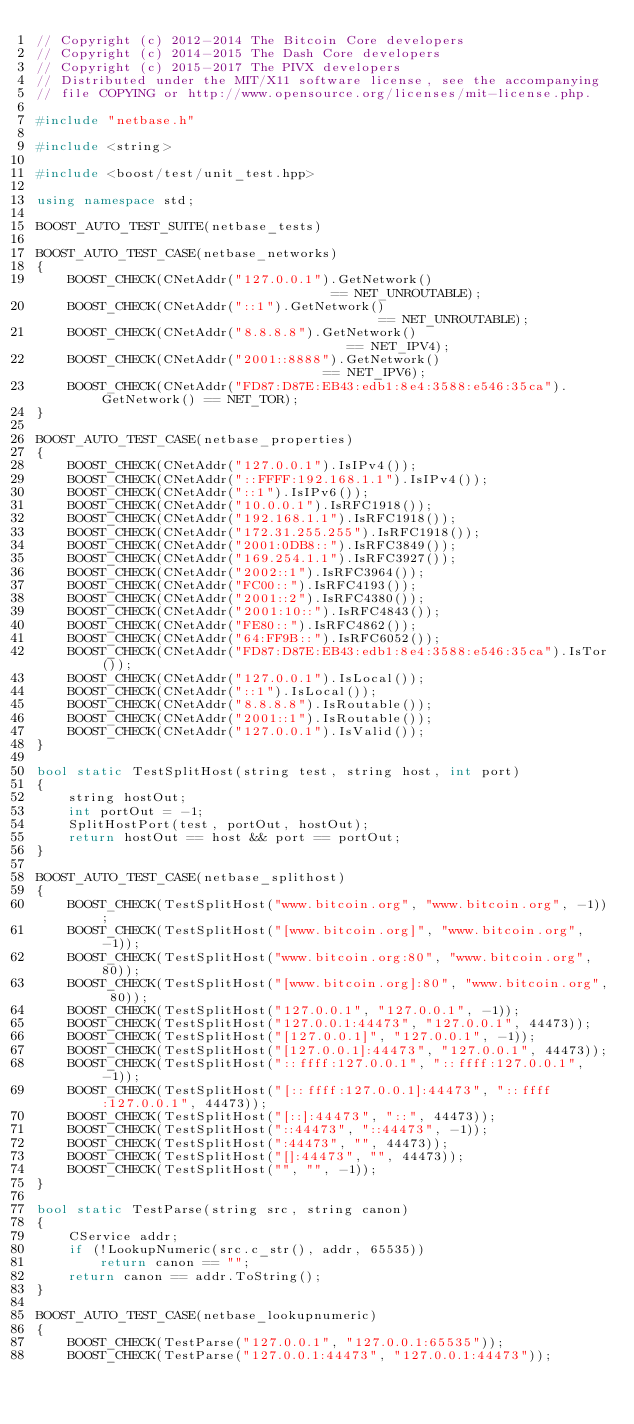Convert code to text. <code><loc_0><loc_0><loc_500><loc_500><_C++_>// Copyright (c) 2012-2014 The Bitcoin Core developers
// Copyright (c) 2014-2015 The Dash Core developers
// Copyright (c) 2015-2017 The PIVX developers
// Distributed under the MIT/X11 software license, see the accompanying
// file COPYING or http://www.opensource.org/licenses/mit-license.php.

#include "netbase.h"

#include <string>

#include <boost/test/unit_test.hpp>

using namespace std;

BOOST_AUTO_TEST_SUITE(netbase_tests)

BOOST_AUTO_TEST_CASE(netbase_networks)
{
    BOOST_CHECK(CNetAddr("127.0.0.1").GetNetwork()                              == NET_UNROUTABLE);
    BOOST_CHECK(CNetAddr("::1").GetNetwork()                                    == NET_UNROUTABLE);
    BOOST_CHECK(CNetAddr("8.8.8.8").GetNetwork()                                == NET_IPV4);
    BOOST_CHECK(CNetAddr("2001::8888").GetNetwork()                             == NET_IPV6);
    BOOST_CHECK(CNetAddr("FD87:D87E:EB43:edb1:8e4:3588:e546:35ca").GetNetwork() == NET_TOR);
}

BOOST_AUTO_TEST_CASE(netbase_properties)
{
    BOOST_CHECK(CNetAddr("127.0.0.1").IsIPv4());
    BOOST_CHECK(CNetAddr("::FFFF:192.168.1.1").IsIPv4());
    BOOST_CHECK(CNetAddr("::1").IsIPv6());
    BOOST_CHECK(CNetAddr("10.0.0.1").IsRFC1918());
    BOOST_CHECK(CNetAddr("192.168.1.1").IsRFC1918());
    BOOST_CHECK(CNetAddr("172.31.255.255").IsRFC1918());
    BOOST_CHECK(CNetAddr("2001:0DB8::").IsRFC3849());
    BOOST_CHECK(CNetAddr("169.254.1.1").IsRFC3927());
    BOOST_CHECK(CNetAddr("2002::1").IsRFC3964());
    BOOST_CHECK(CNetAddr("FC00::").IsRFC4193());
    BOOST_CHECK(CNetAddr("2001::2").IsRFC4380());
    BOOST_CHECK(CNetAddr("2001:10::").IsRFC4843());
    BOOST_CHECK(CNetAddr("FE80::").IsRFC4862());
    BOOST_CHECK(CNetAddr("64:FF9B::").IsRFC6052());
    BOOST_CHECK(CNetAddr("FD87:D87E:EB43:edb1:8e4:3588:e546:35ca").IsTor());
    BOOST_CHECK(CNetAddr("127.0.0.1").IsLocal());
    BOOST_CHECK(CNetAddr("::1").IsLocal());
    BOOST_CHECK(CNetAddr("8.8.8.8").IsRoutable());
    BOOST_CHECK(CNetAddr("2001::1").IsRoutable());
    BOOST_CHECK(CNetAddr("127.0.0.1").IsValid());
}

bool static TestSplitHost(string test, string host, int port)
{
    string hostOut;
    int portOut = -1;
    SplitHostPort(test, portOut, hostOut);
    return hostOut == host && port == portOut;
}

BOOST_AUTO_TEST_CASE(netbase_splithost)
{
    BOOST_CHECK(TestSplitHost("www.bitcoin.org", "www.bitcoin.org", -1));
    BOOST_CHECK(TestSplitHost("[www.bitcoin.org]", "www.bitcoin.org", -1));
    BOOST_CHECK(TestSplitHost("www.bitcoin.org:80", "www.bitcoin.org", 80));
    BOOST_CHECK(TestSplitHost("[www.bitcoin.org]:80", "www.bitcoin.org", 80));
    BOOST_CHECK(TestSplitHost("127.0.0.1", "127.0.0.1", -1));
    BOOST_CHECK(TestSplitHost("127.0.0.1:44473", "127.0.0.1", 44473));
    BOOST_CHECK(TestSplitHost("[127.0.0.1]", "127.0.0.1", -1));
    BOOST_CHECK(TestSplitHost("[127.0.0.1]:44473", "127.0.0.1", 44473));
    BOOST_CHECK(TestSplitHost("::ffff:127.0.0.1", "::ffff:127.0.0.1", -1));
    BOOST_CHECK(TestSplitHost("[::ffff:127.0.0.1]:44473", "::ffff:127.0.0.1", 44473));
    BOOST_CHECK(TestSplitHost("[::]:44473", "::", 44473));
    BOOST_CHECK(TestSplitHost("::44473", "::44473", -1));
    BOOST_CHECK(TestSplitHost(":44473", "", 44473));
    BOOST_CHECK(TestSplitHost("[]:44473", "", 44473));
    BOOST_CHECK(TestSplitHost("", "", -1));
}

bool static TestParse(string src, string canon)
{
    CService addr;
    if (!LookupNumeric(src.c_str(), addr, 65535))
        return canon == "";
    return canon == addr.ToString();
}

BOOST_AUTO_TEST_CASE(netbase_lookupnumeric)
{
    BOOST_CHECK(TestParse("127.0.0.1", "127.0.0.1:65535"));
    BOOST_CHECK(TestParse("127.0.0.1:44473", "127.0.0.1:44473"));</code> 